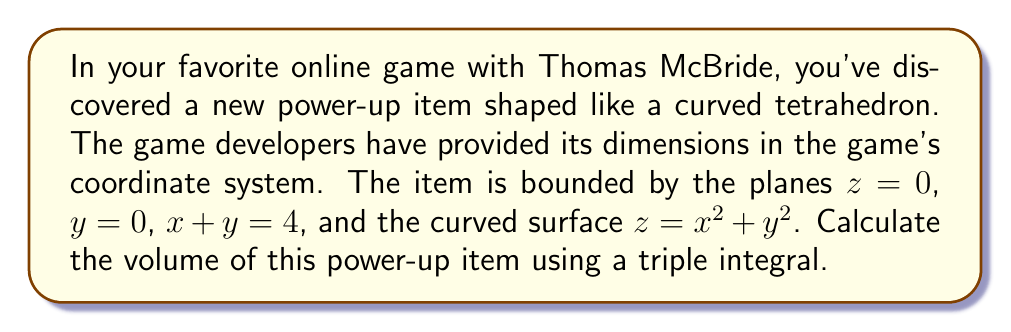What is the answer to this math problem? Let's approach this step-by-step:

1) We need to set up a triple integral to calculate the volume. The general form is:

   $$V = \iiint_R dV = \iiint_R dxdydz$$

2) We need to determine the limits of integration. From the given boundaries:
   - $z$ ranges from 0 to $x^2+y^2$
   - $y$ ranges from 0 to $4-x$ (derived from $x+y=4$)
   - $x$ ranges from 0 to 4

3) Setting up the triple integral:

   $$V = \int_0^4 \int_0^{4-x} \int_0^{x^2+y^2} dz dy dx$$

4) Let's solve the innermost integral first:

   $$V = \int_0^4 \int_0^{4-x} [z]_0^{x^2+y^2} dy dx = \int_0^4 \int_0^{4-x} (x^2+y^2) dy dx$$

5) Now, let's solve the integral with respect to $y$:

   $$V = \int_0^4 [\frac{1}{3}y^3 + x^2y]_0^{4-x} dx = \int_0^4 [\frac{1}{3}(4-x)^3 + x^2(4-x)] dx$$

6) Expand the expression:

   $$V = \int_0^4 [\frac{64}{3} - 16x + 4x^2 - \frac{1}{3}x^3 + 4x^2 - x^3] dx$$

7) Simplify:

   $$V = \int_0^4 [\frac{64}{3} - 16x + 8x^2 - \frac{4}{3}x^3] dx$$

8) Integrate with respect to $x$:

   $$V = [\frac{64}{3}x - 8x^2 + \frac{8}{3}x^3 - \frac{1}{3}x^4]_0^4$$

9) Evaluate the integral:

   $$V = [\frac{256}{3} - 128 + \frac{512}{3} - \frac{256}{3}] - [0] = \frac{384}{3} = 128$$

Therefore, the volume of the power-up item is 128 cubic units in the game's coordinate system.
Answer: 128 cubic units 